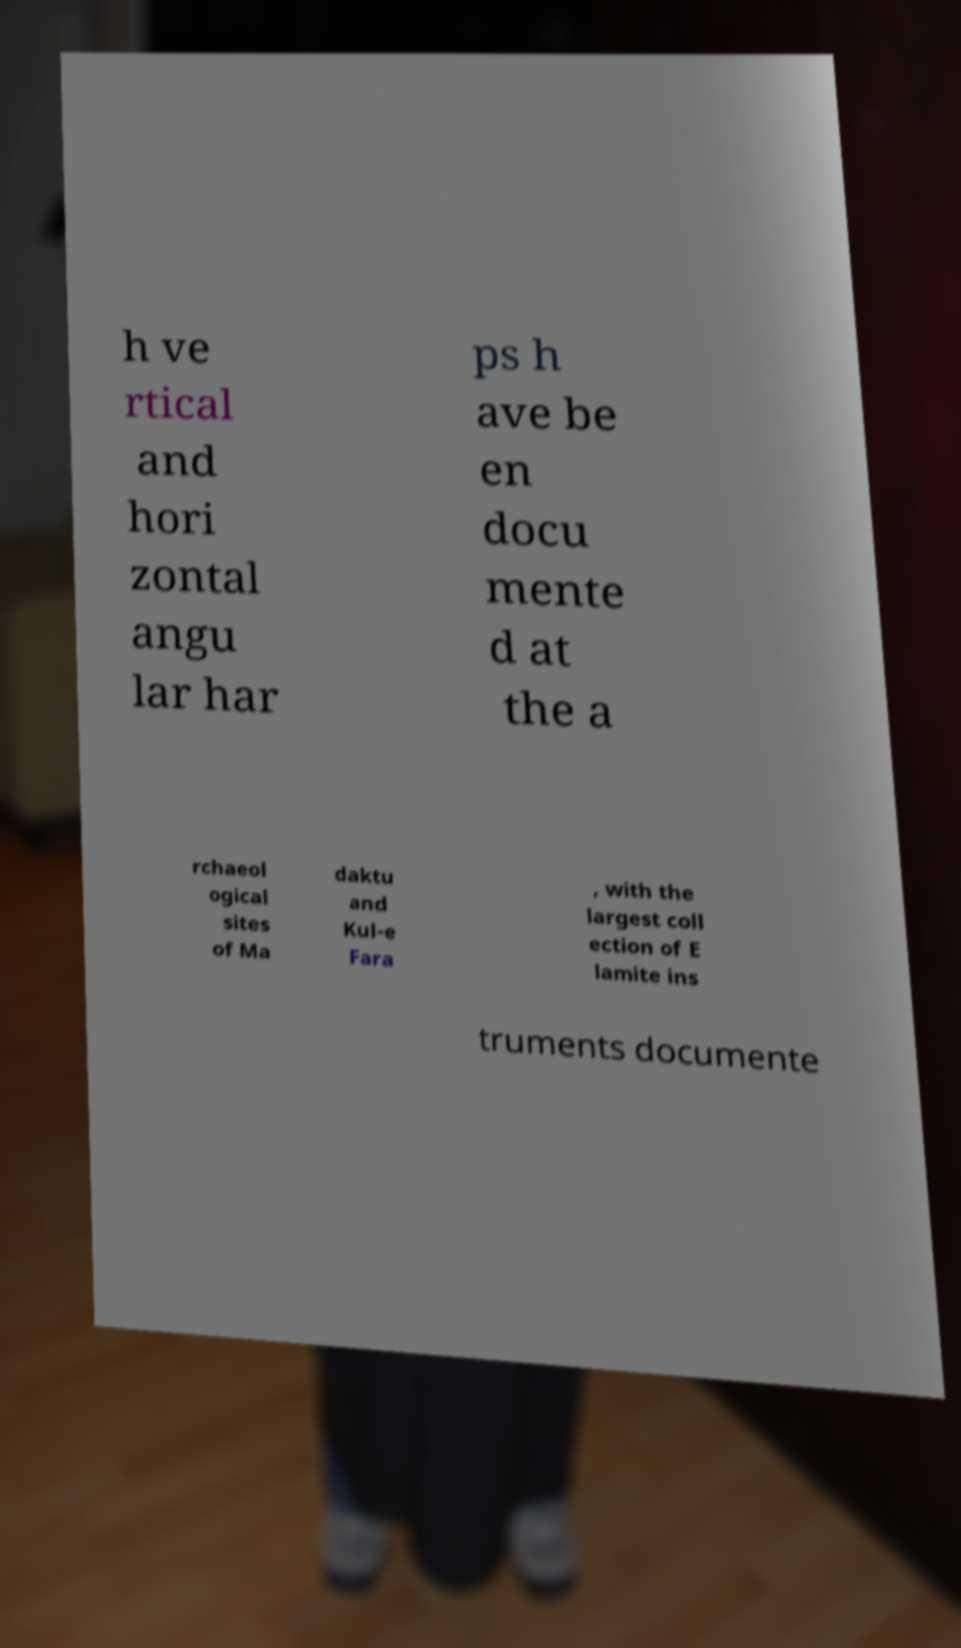Can you accurately transcribe the text from the provided image for me? h ve rtical and hori zontal angu lar har ps h ave be en docu mente d at the a rchaeol ogical sites of Ma daktu and Kul-e Fara , with the largest coll ection of E lamite ins truments documente 